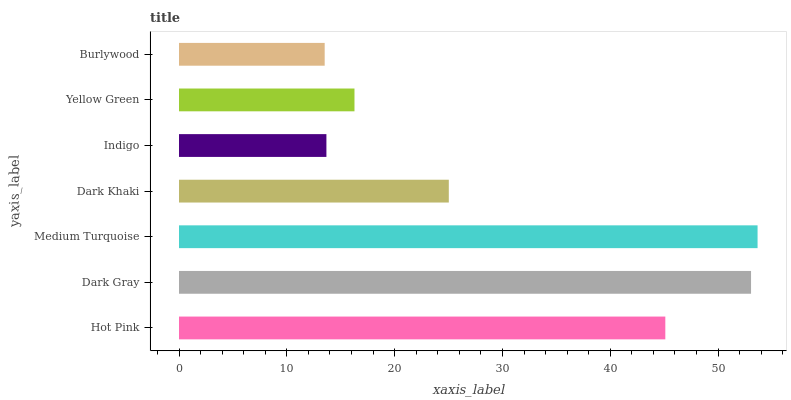Is Burlywood the minimum?
Answer yes or no. Yes. Is Medium Turquoise the maximum?
Answer yes or no. Yes. Is Dark Gray the minimum?
Answer yes or no. No. Is Dark Gray the maximum?
Answer yes or no. No. Is Dark Gray greater than Hot Pink?
Answer yes or no. Yes. Is Hot Pink less than Dark Gray?
Answer yes or no. Yes. Is Hot Pink greater than Dark Gray?
Answer yes or no. No. Is Dark Gray less than Hot Pink?
Answer yes or no. No. Is Dark Khaki the high median?
Answer yes or no. Yes. Is Dark Khaki the low median?
Answer yes or no. Yes. Is Yellow Green the high median?
Answer yes or no. No. Is Medium Turquoise the low median?
Answer yes or no. No. 